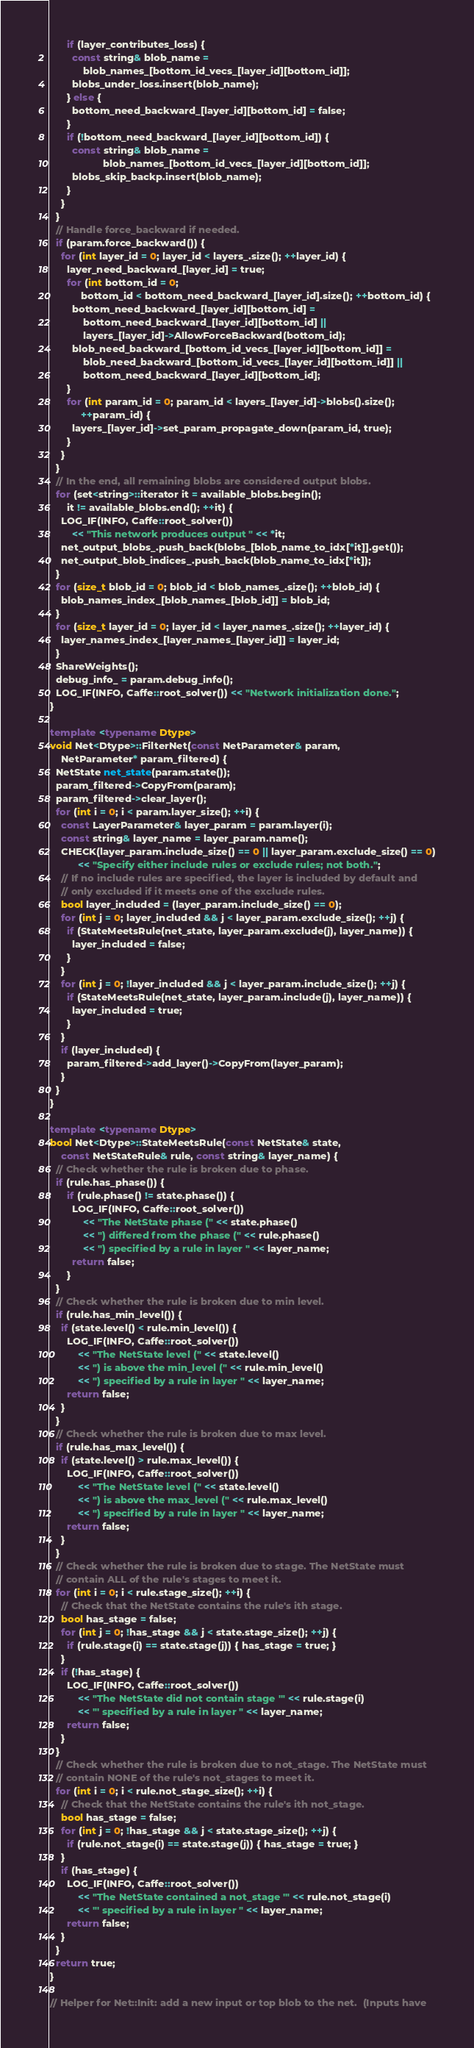<code> <loc_0><loc_0><loc_500><loc_500><_C++_>      if (layer_contributes_loss) {
        const string& blob_name =
            blob_names_[bottom_id_vecs_[layer_id][bottom_id]];
        blobs_under_loss.insert(blob_name);
      } else {
        bottom_need_backward_[layer_id][bottom_id] = false;
      }
      if (!bottom_need_backward_[layer_id][bottom_id]) {
        const string& blob_name =
                   blob_names_[bottom_id_vecs_[layer_id][bottom_id]];
        blobs_skip_backp.insert(blob_name);
      }
    }
  }
  // Handle force_backward if needed.
  if (param.force_backward()) {
    for (int layer_id = 0; layer_id < layers_.size(); ++layer_id) {
      layer_need_backward_[layer_id] = true;
      for (int bottom_id = 0;
           bottom_id < bottom_need_backward_[layer_id].size(); ++bottom_id) {
        bottom_need_backward_[layer_id][bottom_id] =
            bottom_need_backward_[layer_id][bottom_id] ||
            layers_[layer_id]->AllowForceBackward(bottom_id);
        blob_need_backward_[bottom_id_vecs_[layer_id][bottom_id]] =
            blob_need_backward_[bottom_id_vecs_[layer_id][bottom_id]] ||
            bottom_need_backward_[layer_id][bottom_id];
      }
      for (int param_id = 0; param_id < layers_[layer_id]->blobs().size();
           ++param_id) {
        layers_[layer_id]->set_param_propagate_down(param_id, true);
      }
    }
  }
  // In the end, all remaining blobs are considered output blobs.
  for (set<string>::iterator it = available_blobs.begin();
      it != available_blobs.end(); ++it) {
    LOG_IF(INFO, Caffe::root_solver())
        << "This network produces output " << *it;
    net_output_blobs_.push_back(blobs_[blob_name_to_idx[*it]].get());
    net_output_blob_indices_.push_back(blob_name_to_idx[*it]);
  }
  for (size_t blob_id = 0; blob_id < blob_names_.size(); ++blob_id) {
    blob_names_index_[blob_names_[blob_id]] = blob_id;
  }
  for (size_t layer_id = 0; layer_id < layer_names_.size(); ++layer_id) {
    layer_names_index_[layer_names_[layer_id]] = layer_id;
  }
  ShareWeights();
  debug_info_ = param.debug_info();
  LOG_IF(INFO, Caffe::root_solver()) << "Network initialization done.";
}

template <typename Dtype>
void Net<Dtype>::FilterNet(const NetParameter& param,
    NetParameter* param_filtered) {
  NetState net_state(param.state());
  param_filtered->CopyFrom(param);
  param_filtered->clear_layer();
  for (int i = 0; i < param.layer_size(); ++i) {
    const LayerParameter& layer_param = param.layer(i);
    const string& layer_name = layer_param.name();
    CHECK(layer_param.include_size() == 0 || layer_param.exclude_size() == 0)
          << "Specify either include rules or exclude rules; not both.";
    // If no include rules are specified, the layer is included by default and
    // only excluded if it meets one of the exclude rules.
    bool layer_included = (layer_param.include_size() == 0);
    for (int j = 0; layer_included && j < layer_param.exclude_size(); ++j) {
      if (StateMeetsRule(net_state, layer_param.exclude(j), layer_name)) {
        layer_included = false;
      }
    }
    for (int j = 0; !layer_included && j < layer_param.include_size(); ++j) {
      if (StateMeetsRule(net_state, layer_param.include(j), layer_name)) {
        layer_included = true;
      }
    }
    if (layer_included) {
      param_filtered->add_layer()->CopyFrom(layer_param);
    }
  }
}

template <typename Dtype>
bool Net<Dtype>::StateMeetsRule(const NetState& state,
    const NetStateRule& rule, const string& layer_name) {
  // Check whether the rule is broken due to phase.
  if (rule.has_phase()) {
      if (rule.phase() != state.phase()) {
        LOG_IF(INFO, Caffe::root_solver())
            << "The NetState phase (" << state.phase()
            << ") differed from the phase (" << rule.phase()
            << ") specified by a rule in layer " << layer_name;
        return false;
      }
  }
  // Check whether the rule is broken due to min level.
  if (rule.has_min_level()) {
    if (state.level() < rule.min_level()) {
      LOG_IF(INFO, Caffe::root_solver())
          << "The NetState level (" << state.level()
          << ") is above the min_level (" << rule.min_level()
          << ") specified by a rule in layer " << layer_name;
      return false;
    }
  }
  // Check whether the rule is broken due to max level.
  if (rule.has_max_level()) {
    if (state.level() > rule.max_level()) {
      LOG_IF(INFO, Caffe::root_solver())
          << "The NetState level (" << state.level()
          << ") is above the max_level (" << rule.max_level()
          << ") specified by a rule in layer " << layer_name;
      return false;
    }
  }
  // Check whether the rule is broken due to stage. The NetState must
  // contain ALL of the rule's stages to meet it.
  for (int i = 0; i < rule.stage_size(); ++i) {
    // Check that the NetState contains the rule's ith stage.
    bool has_stage = false;
    for (int j = 0; !has_stage && j < state.stage_size(); ++j) {
      if (rule.stage(i) == state.stage(j)) { has_stage = true; }
    }
    if (!has_stage) {
      LOG_IF(INFO, Caffe::root_solver())
          << "The NetState did not contain stage '" << rule.stage(i)
          << "' specified by a rule in layer " << layer_name;
      return false;
    }
  }
  // Check whether the rule is broken due to not_stage. The NetState must
  // contain NONE of the rule's not_stages to meet it.
  for (int i = 0; i < rule.not_stage_size(); ++i) {
    // Check that the NetState contains the rule's ith not_stage.
    bool has_stage = false;
    for (int j = 0; !has_stage && j < state.stage_size(); ++j) {
      if (rule.not_stage(i) == state.stage(j)) { has_stage = true; }
    }
    if (has_stage) {
      LOG_IF(INFO, Caffe::root_solver())
          << "The NetState contained a not_stage '" << rule.not_stage(i)
          << "' specified by a rule in layer " << layer_name;
      return false;
    }
  }
  return true;
}

// Helper for Net::Init: add a new input or top blob to the net.  (Inputs have</code> 